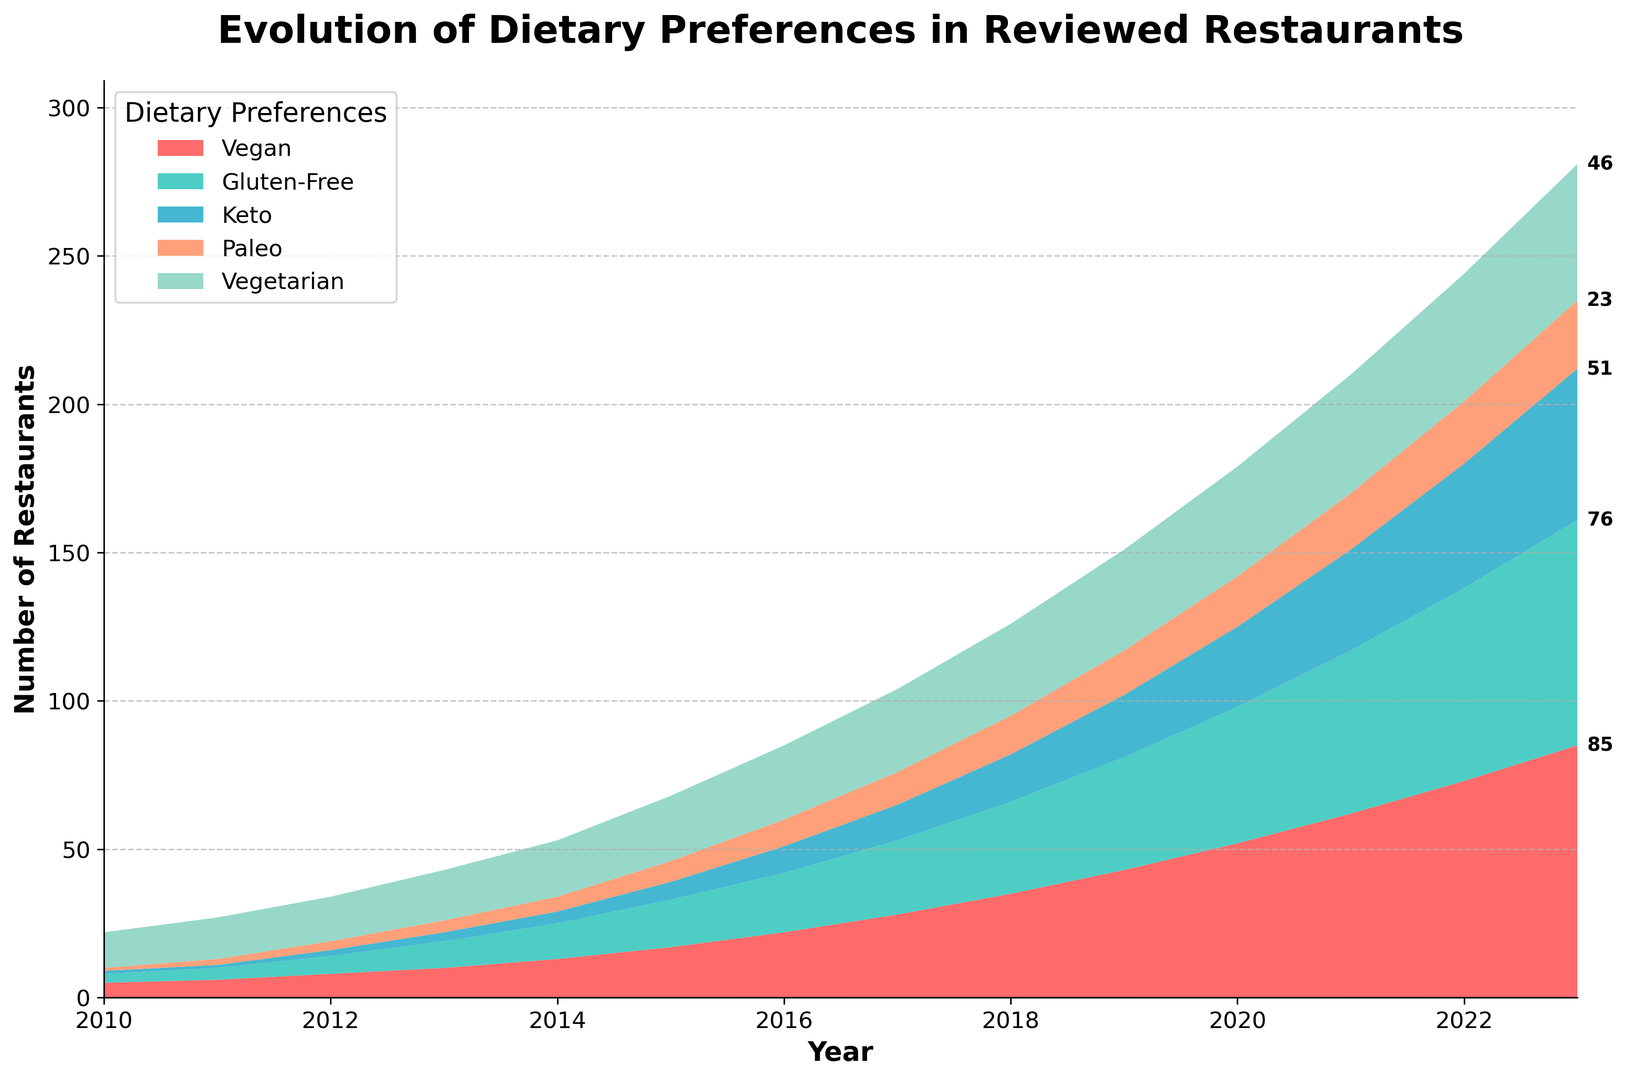What trend do you observe in the number of vegan restaurants from 2010 to 2023? The number of vegan restaurants consistently increases from 5 in 2010 to 85 in 2023. This shows a clear upward trend.
Answer: Increasing Which dietary preference shows the greatest increase in the number of restaurants from 2010 to 2023? The vegan category increased from 5 in 2010 to 85 in 2023, which is the largest increase among the categories.
Answer: Vegan How does the growth of gluten-free restaurants compare to keto restaurants between 2010 and 2023? Gluten-free restaurants grew from 3 in 2010 to 76 in 2023, while keto restaurants grew from 1 to 51 in the same period. The growth in gluten-free restaurants is greater than that of keto restaurants.
Answer: Gluten-free has greater growth In which year did the number of vegetarian restaurants first surpass 30? By inspecting the figure, in 2018 the number of vegetarian restaurants is 31, which is the first year it surpasses 30.
Answer: 2018 What is the combined total number of vegan and paleo restaurants in 2015? According to the figure, there are 17 vegan and 7 paleo restaurants in 2015. Adding them together gives 17 + 7 = 24.
Answer: 24 What is the difference in the number of gluten-free restaurants between 2013 and 2018? In 2013 there are 9 gluten-free restaurants and in 2018 there are 31. The difference is 31 - 9 = 22.
Answer: 22 Which dietary preference had the least number of restaurants in 2021? Checking the number of restaurants for each category in 2021, the paleo category has 19 restaurants, which is the least.
Answer: Paleo How much did the number of vegetarian restaurants increase from 2010 to 2023? The number of vegetarian restaurants increased from 12 in 2010 to 46 in 2023. The increase is 46 - 12 = 34.
Answer: 34 In what year did keto restaurants start to grow significantly? The growth of keto restaurants begins to pick up noticeably after 2015, where it jumps from 4 in 2014 to 6 in 2015.
Answer: 2015 Which dietary preference shows the most consistent growth throughout all years? Inspecting the trends, vegan restaurants show a consistent and steady growth each year.
Answer: Vegan 